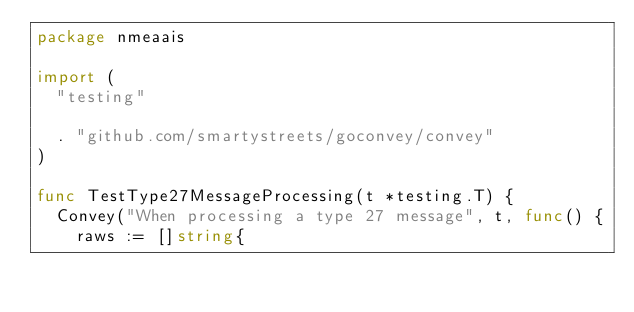<code> <loc_0><loc_0><loc_500><loc_500><_Go_>package nmeaais

import (
	"testing"

	. "github.com/smartystreets/goconvey/convey"
)

func TestType27MessageProcessing(t *testing.T) {
	Convey("When processing a type 27 message", t, func() {
		raws := []string{</code> 